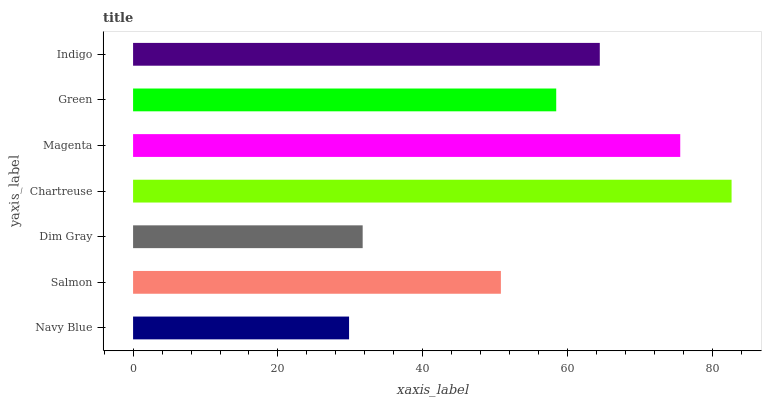Is Navy Blue the minimum?
Answer yes or no. Yes. Is Chartreuse the maximum?
Answer yes or no. Yes. Is Salmon the minimum?
Answer yes or no. No. Is Salmon the maximum?
Answer yes or no. No. Is Salmon greater than Navy Blue?
Answer yes or no. Yes. Is Navy Blue less than Salmon?
Answer yes or no. Yes. Is Navy Blue greater than Salmon?
Answer yes or no. No. Is Salmon less than Navy Blue?
Answer yes or no. No. Is Green the high median?
Answer yes or no. Yes. Is Green the low median?
Answer yes or no. Yes. Is Magenta the high median?
Answer yes or no. No. Is Dim Gray the low median?
Answer yes or no. No. 